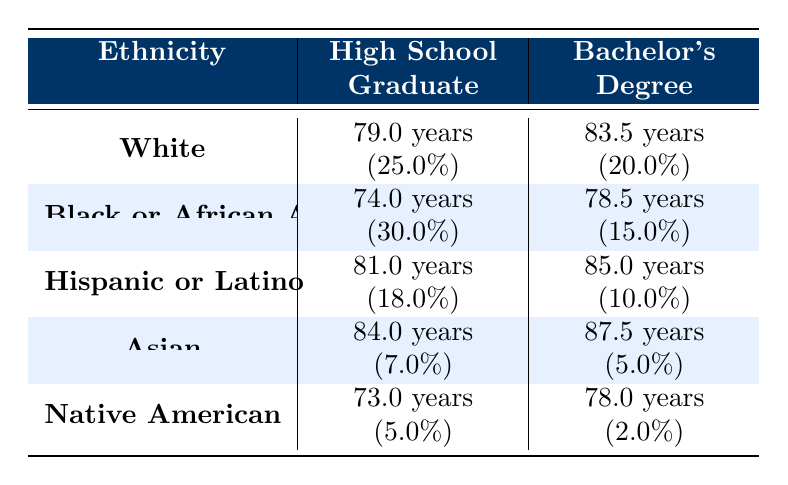What is the life expectancy for White high school graduates? The table shows that the life expectancy for White high school graduates is 79.0 years.
Answer: 79.0 years Which ethnicity has the highest life expectancy for those with a bachelor's degree? According to the table, Asians have the highest life expectancy for those with a bachelor's degree at 87.5 years.
Answer: 87.5 years Is the life expectancy of Native American high school graduates less than that of Black or African American high school graduates? The life expectancy for Native American high school graduates is 73.0 years, while it is 74.0 years for Black or African American high school graduates. Since 73.0 is less than 74.0, the statement is true.
Answer: Yes What is the difference in life expectancy between Hispanic or Latino high school graduates and Asian bachelor’s degree holders? The life expectancy for Hispanic or Latino high school graduates is 81.0 years, while for Asian bachelor’s degree holders, it is 87.5 years. The difference is 87.5 - 81.0 = 6.5 years.
Answer: 6.5 years What percentage of the population are high school graduates among Black or African American individuals? The table indicates that 30.0% of the Black or African American population are high school graduates.
Answer: 30.0% What is the average life expectancy for all ethnicities with a bachelor's degree? To find this average, we will sum the life expectancies for bachelor's degree holders: 83.5 (White) + 78.5 (Black or African American) + 85.0 (Hispanic or Latino) + 87.5 (Asian) + 78.0 (Native American) = 412.5 years. There are 5 ethnicities, so the average is 412.5 / 5 = 82.5 years.
Answer: 82.5 years Is the proportion of the Asian population with a bachelor's degree greater than that of the Hispanic or Latino population? The percentage of the Asian population with a bachelor's degree is 5.0%, while for the Hispanic or Latino population, it is 10.0%. Therefore, the statement that the Asian bachelor's degree proportion is greater is false.
Answer: No Which ethnicity has a life expectancy of less than 75 years for high school graduates? From the table, Black or African American (74.0 years) and Native American (73.0 years) have life expectancies of less than 75 years for high school graduates.
Answer: Black or African American and Native American 